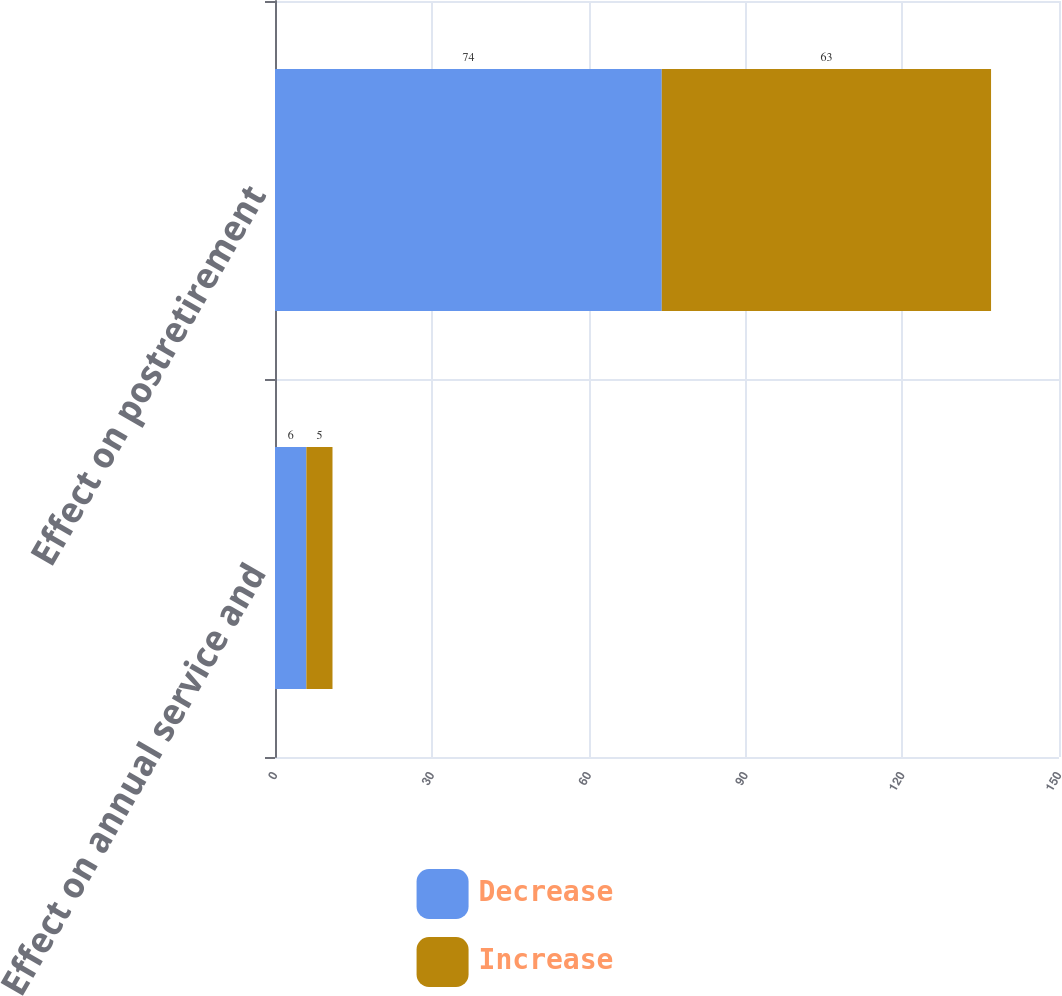<chart> <loc_0><loc_0><loc_500><loc_500><stacked_bar_chart><ecel><fcel>Effect on annual service and<fcel>Effect on postretirement<nl><fcel>Decrease<fcel>6<fcel>74<nl><fcel>Increase<fcel>5<fcel>63<nl></chart> 